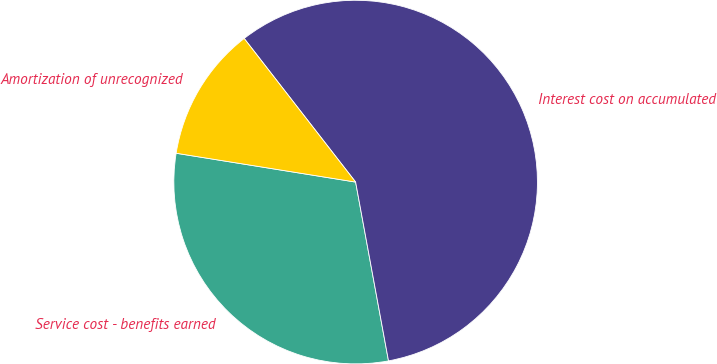<chart> <loc_0><loc_0><loc_500><loc_500><pie_chart><fcel>Service cost - benefits earned<fcel>Interest cost on accumulated<fcel>Amortization of unrecognized<nl><fcel>30.43%<fcel>57.61%<fcel>11.96%<nl></chart> 